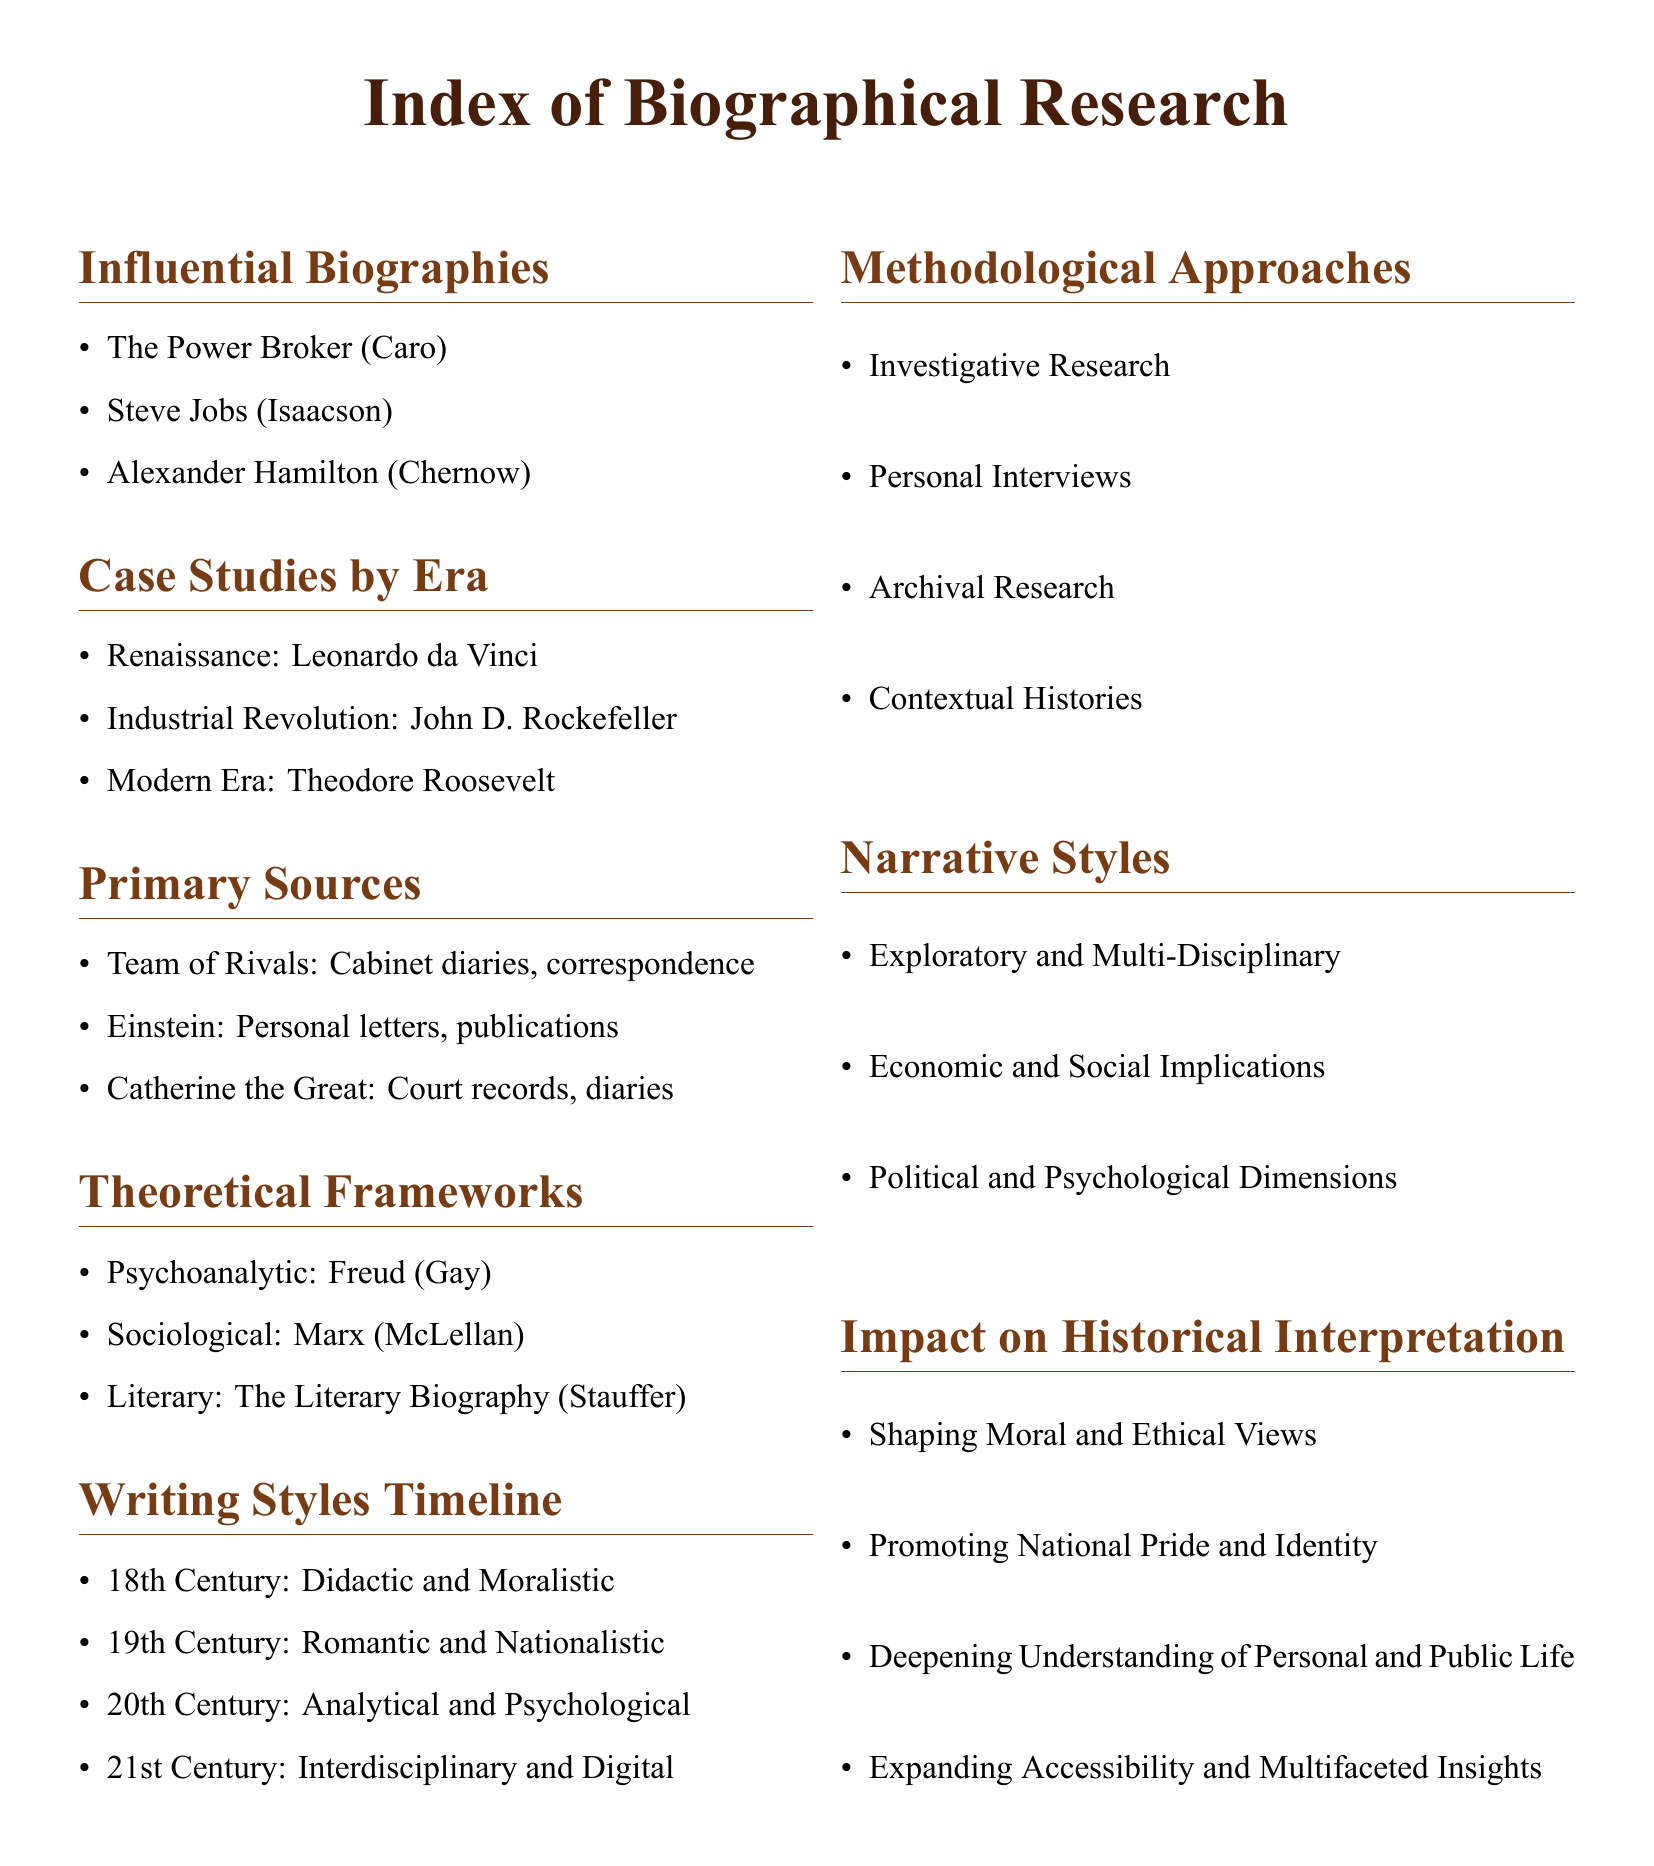what is the title of the biography by Caro? The title mentioned in the document is "The Power Broker" by Caro.
Answer: The Power Broker which biography focuses on Catherine the Great? The document states that "Catherine the Great" references court records and diaries as primary sources.
Answer: Catherine the Great how many case studies from the Renaissance period are listed? There is one case study from the Renaissance period listed in the document, which is Leonardo da Vinci.
Answer: 1 which theoretical framework is associated with Freud? The psychoanalytic theoretical framework is mentioned in connection with Freud in the document.
Answer: Psychoanalytic what writing style is described for the 19th Century? The document describes the writing style of the 19th Century as Romantic and Nationalistic.
Answer: Romantic and Nationalistic name one methodological approach listed in the document. The document lists several methodological approaches, one of which is Investigative Research.
Answer: Investigative Research what narrative style emphasizes political and psychological dimensions? The document indicates that one of the narrative styles is focused on political and psychological dimensions.
Answer: Political and Psychological Dimensions how many influential biographies are mentioned? The document mentions three influential biographies in the "Influential Biographies" section.
Answer: 3 